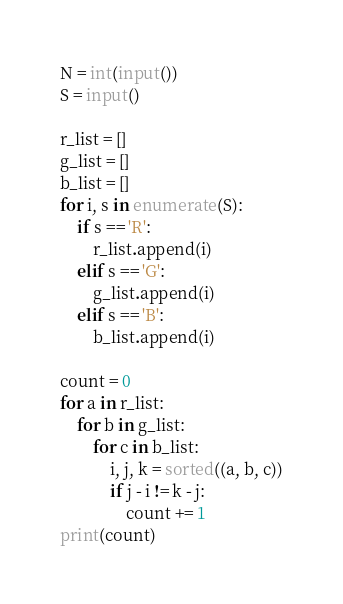Convert code to text. <code><loc_0><loc_0><loc_500><loc_500><_Python_>N = int(input())
S = input()

r_list = []
g_list = []
b_list = []
for i, s in enumerate(S):
    if s == 'R':
        r_list.append(i)
    elif s == 'G':
        g_list.append(i)
    elif s == 'B':
        b_list.append(i)

count = 0
for a in r_list:
    for b in g_list:
        for c in b_list:
            i, j, k = sorted((a, b, c))
            if j - i != k - j:
                count += 1
print(count)</code> 